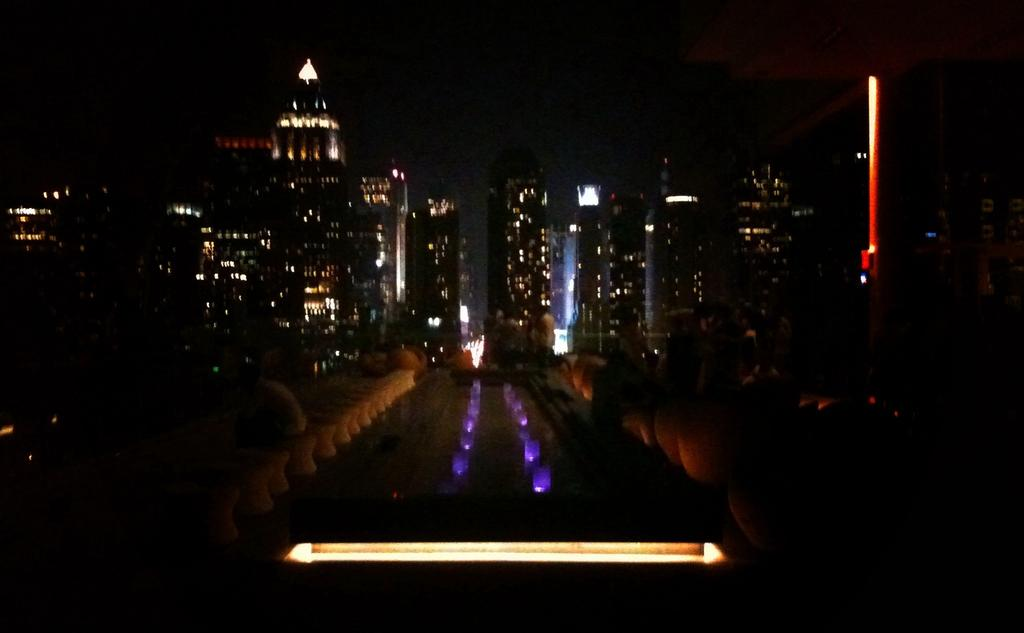What is the source of light at the bottom of the image? There is light at the bottom of the image. What can be seen in the background of the image? There are buildings and towers in the background of the image. What is located at the bottom of the image? There is a walkway at the bottom of the image. What else is present at the bottom of the image besides the walkway? There are objects and lights at the bottom of the image. How many knees are visible in the image? There are no knees visible in the image. What type of stove is present in the image? There is no stove present in the image. 